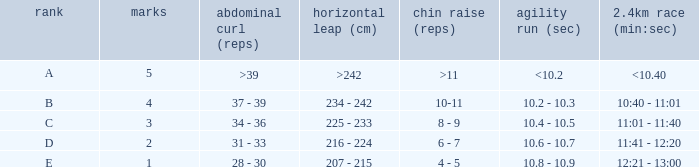Tell me the shuttle run with grade c 10.4 - 10.5. 